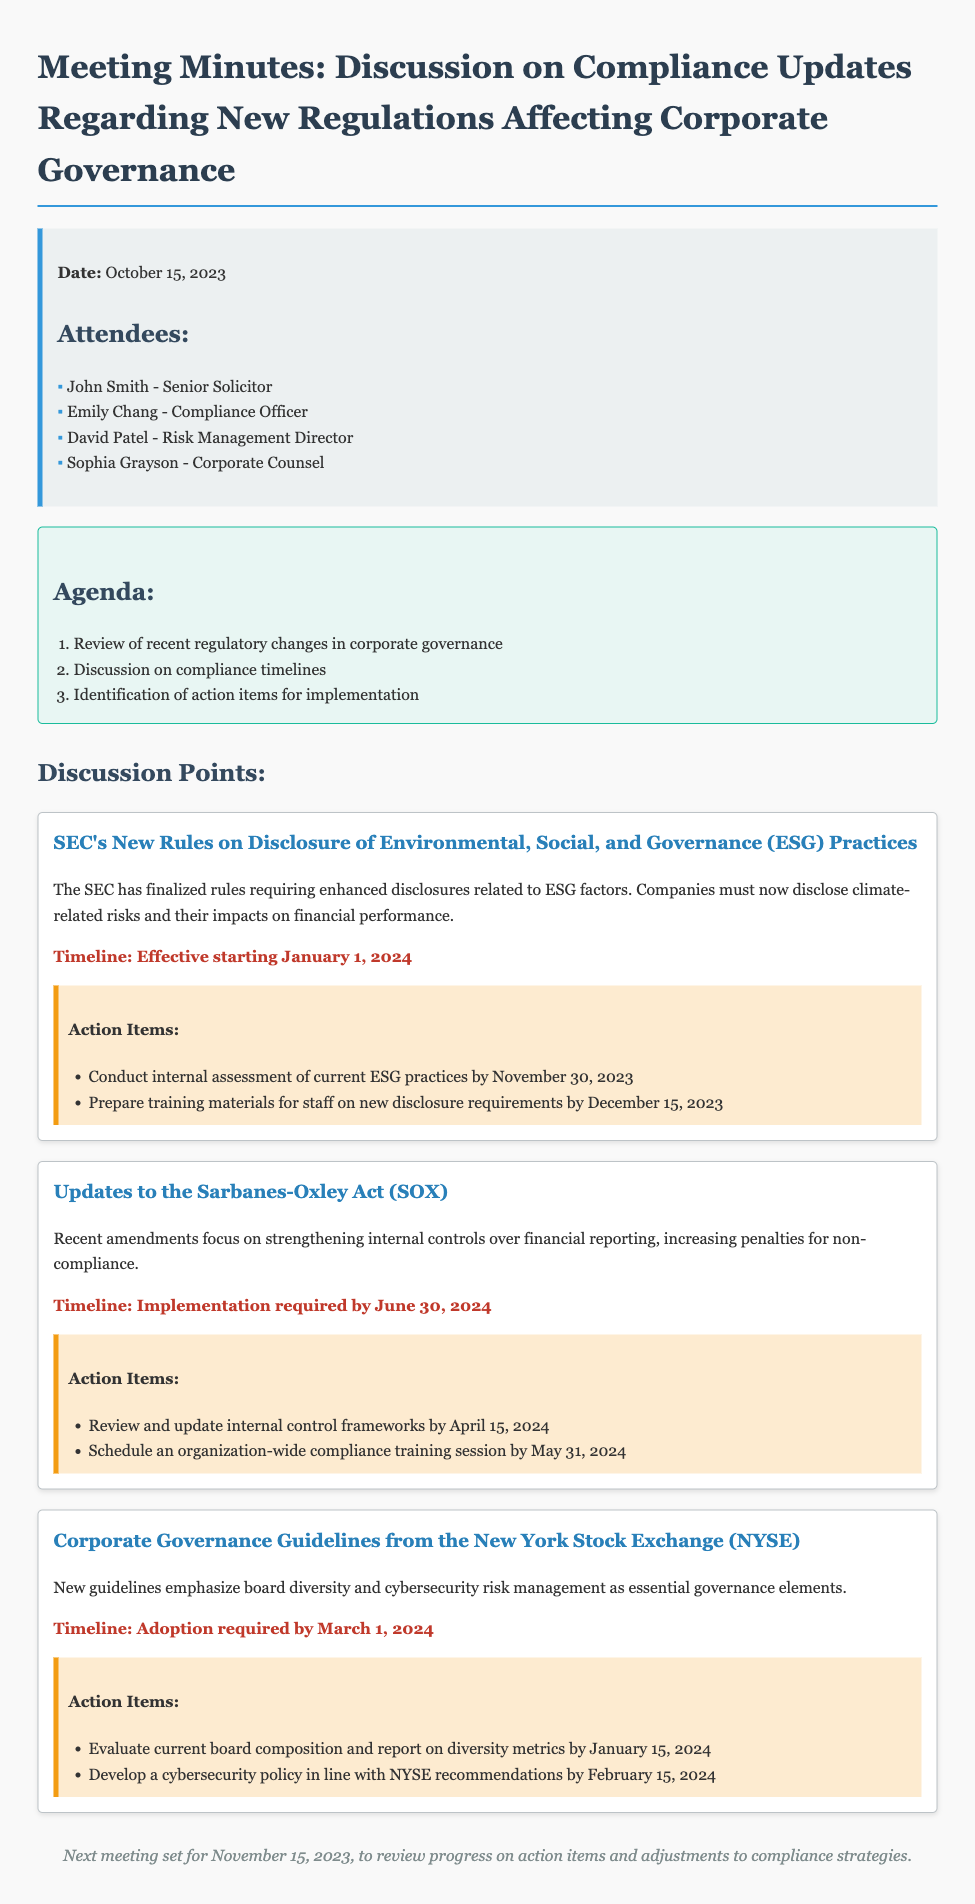What is the date of the meeting? The date of the meeting is mentioned at the beginning of the document.
Answer: October 15, 2023 Who is the Compliance Officer attending the meeting? The attendees section lists the names and titles of those present at the meeting.
Answer: Emily Chang What is the timeline for the SEC's new rules on ESG disclosures? The timeline for this discussion point is stated clearly in the text following the description.
Answer: January 1, 2024 What is the deadline for evaluating board composition regarding NYSE guidelines? This deadline is specified in the action items related to the NYSE guidelines.
Answer: January 15, 2024 How many action items are listed for the Sarbanes-Oxley Act updates? The document lists the action items under each discussion point, which can be counted.
Answer: Two What is the primary focus of the new NYSE guidelines? The document describes the main aspects of the guidelines in the discussion point section.
Answer: Board diversity and cybersecurity risk management When is the next meeting scheduled? The conclusion section mentions the date for the next meeting explicitly.
Answer: November 15, 2023 What is the timeline for the implementation of SOX updates? The timeline for the Sarbanes-Oxley Act updates is clearly indicated in the discussion point section.
Answer: June 30, 2024 What action is required by December 15, 2023, concerning ESG practices? The action item specifically mentions preparation pertaining to ESG requirements.
Answer: Prepare training materials for staff on new disclosure requirements 